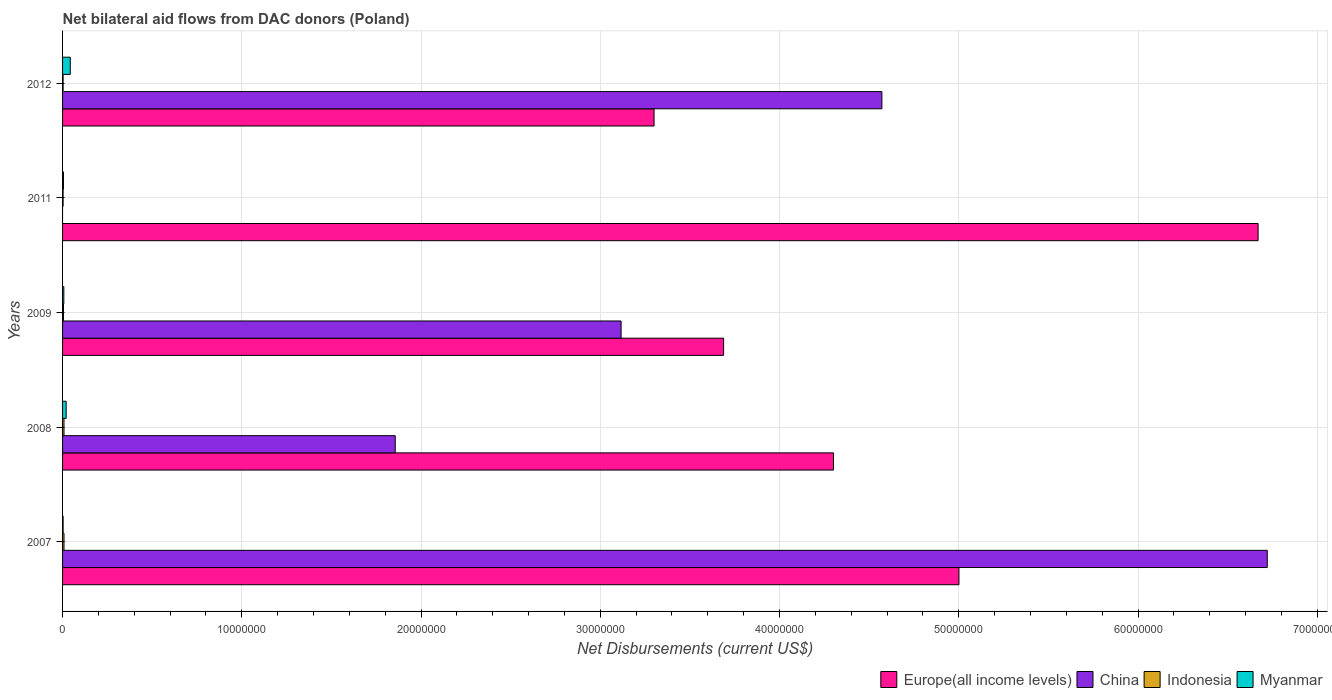How many different coloured bars are there?
Offer a very short reply. 4. How many groups of bars are there?
Offer a very short reply. 5. How many bars are there on the 3rd tick from the bottom?
Ensure brevity in your answer.  4. In how many cases, is the number of bars for a given year not equal to the number of legend labels?
Provide a succinct answer. 1. What is the net bilateral aid flows in Europe(all income levels) in 2007?
Ensure brevity in your answer.  5.00e+07. Across all years, what is the maximum net bilateral aid flows in Europe(all income levels)?
Ensure brevity in your answer.  6.67e+07. What is the total net bilateral aid flows in China in the graph?
Give a very brief answer. 1.63e+08. What is the difference between the net bilateral aid flows in Europe(all income levels) in 2007 and that in 2011?
Your answer should be very brief. -1.67e+07. What is the difference between the net bilateral aid flows in Indonesia in 2007 and the net bilateral aid flows in Europe(all income levels) in 2012?
Your answer should be compact. -3.29e+07. What is the average net bilateral aid flows in Europe(all income levels) per year?
Make the answer very short. 4.59e+07. In the year 2007, what is the difference between the net bilateral aid flows in Indonesia and net bilateral aid flows in Europe(all income levels)?
Offer a very short reply. -4.99e+07. In how many years, is the net bilateral aid flows in China greater than 46000000 US$?
Provide a succinct answer. 1. What is the ratio of the net bilateral aid flows in Europe(all income levels) in 2008 to that in 2012?
Offer a terse response. 1.3. Is the net bilateral aid flows in Europe(all income levels) in 2007 less than that in 2009?
Make the answer very short. No. What is the difference between the highest and the second highest net bilateral aid flows in Europe(all income levels)?
Your answer should be compact. 1.67e+07. What is the difference between the highest and the lowest net bilateral aid flows in Indonesia?
Your answer should be very brief. 5.00e+04. In how many years, is the net bilateral aid flows in Myanmar greater than the average net bilateral aid flows in Myanmar taken over all years?
Your answer should be very brief. 2. Is it the case that in every year, the sum of the net bilateral aid flows in China and net bilateral aid flows in Indonesia is greater than the sum of net bilateral aid flows in Myanmar and net bilateral aid flows in Europe(all income levels)?
Give a very brief answer. No. Are the values on the major ticks of X-axis written in scientific E-notation?
Make the answer very short. No. Does the graph contain any zero values?
Your response must be concise. Yes. How are the legend labels stacked?
Make the answer very short. Horizontal. What is the title of the graph?
Your response must be concise. Net bilateral aid flows from DAC donors (Poland). What is the label or title of the X-axis?
Ensure brevity in your answer.  Net Disbursements (current US$). What is the label or title of the Y-axis?
Your answer should be compact. Years. What is the Net Disbursements (current US$) in Europe(all income levels) in 2007?
Your answer should be compact. 5.00e+07. What is the Net Disbursements (current US$) in China in 2007?
Your response must be concise. 6.72e+07. What is the Net Disbursements (current US$) of Indonesia in 2007?
Provide a short and direct response. 8.00e+04. What is the Net Disbursements (current US$) in Myanmar in 2007?
Provide a succinct answer. 3.00e+04. What is the Net Disbursements (current US$) of Europe(all income levels) in 2008?
Ensure brevity in your answer.  4.30e+07. What is the Net Disbursements (current US$) in China in 2008?
Ensure brevity in your answer.  1.86e+07. What is the Net Disbursements (current US$) in Indonesia in 2008?
Your answer should be compact. 8.00e+04. What is the Net Disbursements (current US$) of Myanmar in 2008?
Offer a terse response. 2.00e+05. What is the Net Disbursements (current US$) of Europe(all income levels) in 2009?
Your answer should be compact. 3.69e+07. What is the Net Disbursements (current US$) of China in 2009?
Offer a terse response. 3.12e+07. What is the Net Disbursements (current US$) of Indonesia in 2009?
Ensure brevity in your answer.  5.00e+04. What is the Net Disbursements (current US$) of Myanmar in 2009?
Offer a very short reply. 7.00e+04. What is the Net Disbursements (current US$) in Europe(all income levels) in 2011?
Give a very brief answer. 6.67e+07. What is the Net Disbursements (current US$) of China in 2011?
Provide a succinct answer. 0. What is the Net Disbursements (current US$) in Indonesia in 2011?
Keep it short and to the point. 3.00e+04. What is the Net Disbursements (current US$) in Europe(all income levels) in 2012?
Your answer should be compact. 3.30e+07. What is the Net Disbursements (current US$) in China in 2012?
Ensure brevity in your answer.  4.57e+07. What is the Net Disbursements (current US$) of Indonesia in 2012?
Your answer should be compact. 3.00e+04. Across all years, what is the maximum Net Disbursements (current US$) of Europe(all income levels)?
Offer a terse response. 6.67e+07. Across all years, what is the maximum Net Disbursements (current US$) in China?
Offer a very short reply. 6.72e+07. Across all years, what is the maximum Net Disbursements (current US$) of Indonesia?
Ensure brevity in your answer.  8.00e+04. Across all years, what is the maximum Net Disbursements (current US$) of Myanmar?
Make the answer very short. 4.30e+05. Across all years, what is the minimum Net Disbursements (current US$) of Europe(all income levels)?
Keep it short and to the point. 3.30e+07. What is the total Net Disbursements (current US$) in Europe(all income levels) in the graph?
Ensure brevity in your answer.  2.30e+08. What is the total Net Disbursements (current US$) of China in the graph?
Provide a succinct answer. 1.63e+08. What is the total Net Disbursements (current US$) of Indonesia in the graph?
Ensure brevity in your answer.  2.70e+05. What is the total Net Disbursements (current US$) in Myanmar in the graph?
Ensure brevity in your answer.  7.80e+05. What is the difference between the Net Disbursements (current US$) in Europe(all income levels) in 2007 and that in 2008?
Provide a short and direct response. 7.00e+06. What is the difference between the Net Disbursements (current US$) of China in 2007 and that in 2008?
Your answer should be compact. 4.86e+07. What is the difference between the Net Disbursements (current US$) of Myanmar in 2007 and that in 2008?
Your response must be concise. -1.70e+05. What is the difference between the Net Disbursements (current US$) in Europe(all income levels) in 2007 and that in 2009?
Your response must be concise. 1.31e+07. What is the difference between the Net Disbursements (current US$) of China in 2007 and that in 2009?
Ensure brevity in your answer.  3.60e+07. What is the difference between the Net Disbursements (current US$) in Europe(all income levels) in 2007 and that in 2011?
Your answer should be very brief. -1.67e+07. What is the difference between the Net Disbursements (current US$) in Indonesia in 2007 and that in 2011?
Offer a terse response. 5.00e+04. What is the difference between the Net Disbursements (current US$) of Europe(all income levels) in 2007 and that in 2012?
Your answer should be very brief. 1.70e+07. What is the difference between the Net Disbursements (current US$) of China in 2007 and that in 2012?
Provide a succinct answer. 2.15e+07. What is the difference between the Net Disbursements (current US$) of Indonesia in 2007 and that in 2012?
Offer a terse response. 5.00e+04. What is the difference between the Net Disbursements (current US$) of Myanmar in 2007 and that in 2012?
Your answer should be compact. -4.00e+05. What is the difference between the Net Disbursements (current US$) in Europe(all income levels) in 2008 and that in 2009?
Offer a very short reply. 6.13e+06. What is the difference between the Net Disbursements (current US$) in China in 2008 and that in 2009?
Keep it short and to the point. -1.26e+07. What is the difference between the Net Disbursements (current US$) of Myanmar in 2008 and that in 2009?
Your answer should be compact. 1.30e+05. What is the difference between the Net Disbursements (current US$) of Europe(all income levels) in 2008 and that in 2011?
Provide a short and direct response. -2.37e+07. What is the difference between the Net Disbursements (current US$) of Indonesia in 2008 and that in 2011?
Your answer should be compact. 5.00e+04. What is the difference between the Net Disbursements (current US$) in Europe(all income levels) in 2008 and that in 2012?
Your answer should be very brief. 1.00e+07. What is the difference between the Net Disbursements (current US$) of China in 2008 and that in 2012?
Make the answer very short. -2.72e+07. What is the difference between the Net Disbursements (current US$) of Indonesia in 2008 and that in 2012?
Your response must be concise. 5.00e+04. What is the difference between the Net Disbursements (current US$) in Europe(all income levels) in 2009 and that in 2011?
Your answer should be very brief. -2.98e+07. What is the difference between the Net Disbursements (current US$) in Indonesia in 2009 and that in 2011?
Ensure brevity in your answer.  2.00e+04. What is the difference between the Net Disbursements (current US$) in Europe(all income levels) in 2009 and that in 2012?
Your answer should be very brief. 3.88e+06. What is the difference between the Net Disbursements (current US$) of China in 2009 and that in 2012?
Provide a short and direct response. -1.46e+07. What is the difference between the Net Disbursements (current US$) of Myanmar in 2009 and that in 2012?
Provide a succinct answer. -3.60e+05. What is the difference between the Net Disbursements (current US$) in Europe(all income levels) in 2011 and that in 2012?
Your answer should be compact. 3.37e+07. What is the difference between the Net Disbursements (current US$) in Myanmar in 2011 and that in 2012?
Ensure brevity in your answer.  -3.80e+05. What is the difference between the Net Disbursements (current US$) in Europe(all income levels) in 2007 and the Net Disbursements (current US$) in China in 2008?
Your answer should be compact. 3.14e+07. What is the difference between the Net Disbursements (current US$) of Europe(all income levels) in 2007 and the Net Disbursements (current US$) of Indonesia in 2008?
Offer a very short reply. 4.99e+07. What is the difference between the Net Disbursements (current US$) in Europe(all income levels) in 2007 and the Net Disbursements (current US$) in Myanmar in 2008?
Your answer should be very brief. 4.98e+07. What is the difference between the Net Disbursements (current US$) of China in 2007 and the Net Disbursements (current US$) of Indonesia in 2008?
Your answer should be compact. 6.71e+07. What is the difference between the Net Disbursements (current US$) in China in 2007 and the Net Disbursements (current US$) in Myanmar in 2008?
Your response must be concise. 6.70e+07. What is the difference between the Net Disbursements (current US$) in Europe(all income levels) in 2007 and the Net Disbursements (current US$) in China in 2009?
Your answer should be very brief. 1.88e+07. What is the difference between the Net Disbursements (current US$) in Europe(all income levels) in 2007 and the Net Disbursements (current US$) in Indonesia in 2009?
Your answer should be very brief. 5.00e+07. What is the difference between the Net Disbursements (current US$) in Europe(all income levels) in 2007 and the Net Disbursements (current US$) in Myanmar in 2009?
Offer a very short reply. 4.99e+07. What is the difference between the Net Disbursements (current US$) of China in 2007 and the Net Disbursements (current US$) of Indonesia in 2009?
Keep it short and to the point. 6.72e+07. What is the difference between the Net Disbursements (current US$) in China in 2007 and the Net Disbursements (current US$) in Myanmar in 2009?
Provide a succinct answer. 6.71e+07. What is the difference between the Net Disbursements (current US$) of Europe(all income levels) in 2007 and the Net Disbursements (current US$) of Indonesia in 2011?
Your answer should be compact. 5.00e+07. What is the difference between the Net Disbursements (current US$) of Europe(all income levels) in 2007 and the Net Disbursements (current US$) of Myanmar in 2011?
Offer a very short reply. 5.00e+07. What is the difference between the Net Disbursements (current US$) of China in 2007 and the Net Disbursements (current US$) of Indonesia in 2011?
Offer a terse response. 6.72e+07. What is the difference between the Net Disbursements (current US$) of China in 2007 and the Net Disbursements (current US$) of Myanmar in 2011?
Provide a short and direct response. 6.72e+07. What is the difference between the Net Disbursements (current US$) in Indonesia in 2007 and the Net Disbursements (current US$) in Myanmar in 2011?
Your answer should be very brief. 3.00e+04. What is the difference between the Net Disbursements (current US$) of Europe(all income levels) in 2007 and the Net Disbursements (current US$) of China in 2012?
Your response must be concise. 4.30e+06. What is the difference between the Net Disbursements (current US$) in Europe(all income levels) in 2007 and the Net Disbursements (current US$) in Indonesia in 2012?
Your response must be concise. 5.00e+07. What is the difference between the Net Disbursements (current US$) in Europe(all income levels) in 2007 and the Net Disbursements (current US$) in Myanmar in 2012?
Ensure brevity in your answer.  4.96e+07. What is the difference between the Net Disbursements (current US$) of China in 2007 and the Net Disbursements (current US$) of Indonesia in 2012?
Offer a terse response. 6.72e+07. What is the difference between the Net Disbursements (current US$) of China in 2007 and the Net Disbursements (current US$) of Myanmar in 2012?
Offer a very short reply. 6.68e+07. What is the difference between the Net Disbursements (current US$) of Indonesia in 2007 and the Net Disbursements (current US$) of Myanmar in 2012?
Provide a succinct answer. -3.50e+05. What is the difference between the Net Disbursements (current US$) in Europe(all income levels) in 2008 and the Net Disbursements (current US$) in China in 2009?
Offer a terse response. 1.18e+07. What is the difference between the Net Disbursements (current US$) of Europe(all income levels) in 2008 and the Net Disbursements (current US$) of Indonesia in 2009?
Offer a terse response. 4.30e+07. What is the difference between the Net Disbursements (current US$) in Europe(all income levels) in 2008 and the Net Disbursements (current US$) in Myanmar in 2009?
Your answer should be compact. 4.29e+07. What is the difference between the Net Disbursements (current US$) in China in 2008 and the Net Disbursements (current US$) in Indonesia in 2009?
Your answer should be very brief. 1.85e+07. What is the difference between the Net Disbursements (current US$) in China in 2008 and the Net Disbursements (current US$) in Myanmar in 2009?
Your response must be concise. 1.85e+07. What is the difference between the Net Disbursements (current US$) of Europe(all income levels) in 2008 and the Net Disbursements (current US$) of Indonesia in 2011?
Your answer should be compact. 4.30e+07. What is the difference between the Net Disbursements (current US$) in Europe(all income levels) in 2008 and the Net Disbursements (current US$) in Myanmar in 2011?
Make the answer very short. 4.30e+07. What is the difference between the Net Disbursements (current US$) of China in 2008 and the Net Disbursements (current US$) of Indonesia in 2011?
Offer a very short reply. 1.85e+07. What is the difference between the Net Disbursements (current US$) of China in 2008 and the Net Disbursements (current US$) of Myanmar in 2011?
Give a very brief answer. 1.85e+07. What is the difference between the Net Disbursements (current US$) in Europe(all income levels) in 2008 and the Net Disbursements (current US$) in China in 2012?
Your answer should be very brief. -2.70e+06. What is the difference between the Net Disbursements (current US$) in Europe(all income levels) in 2008 and the Net Disbursements (current US$) in Indonesia in 2012?
Your answer should be compact. 4.30e+07. What is the difference between the Net Disbursements (current US$) in Europe(all income levels) in 2008 and the Net Disbursements (current US$) in Myanmar in 2012?
Ensure brevity in your answer.  4.26e+07. What is the difference between the Net Disbursements (current US$) in China in 2008 and the Net Disbursements (current US$) in Indonesia in 2012?
Your response must be concise. 1.85e+07. What is the difference between the Net Disbursements (current US$) in China in 2008 and the Net Disbursements (current US$) in Myanmar in 2012?
Your answer should be compact. 1.81e+07. What is the difference between the Net Disbursements (current US$) in Indonesia in 2008 and the Net Disbursements (current US$) in Myanmar in 2012?
Make the answer very short. -3.50e+05. What is the difference between the Net Disbursements (current US$) in Europe(all income levels) in 2009 and the Net Disbursements (current US$) in Indonesia in 2011?
Provide a short and direct response. 3.68e+07. What is the difference between the Net Disbursements (current US$) in Europe(all income levels) in 2009 and the Net Disbursements (current US$) in Myanmar in 2011?
Your answer should be very brief. 3.68e+07. What is the difference between the Net Disbursements (current US$) of China in 2009 and the Net Disbursements (current US$) of Indonesia in 2011?
Provide a short and direct response. 3.11e+07. What is the difference between the Net Disbursements (current US$) in China in 2009 and the Net Disbursements (current US$) in Myanmar in 2011?
Your answer should be very brief. 3.11e+07. What is the difference between the Net Disbursements (current US$) in Indonesia in 2009 and the Net Disbursements (current US$) in Myanmar in 2011?
Keep it short and to the point. 0. What is the difference between the Net Disbursements (current US$) of Europe(all income levels) in 2009 and the Net Disbursements (current US$) of China in 2012?
Make the answer very short. -8.83e+06. What is the difference between the Net Disbursements (current US$) of Europe(all income levels) in 2009 and the Net Disbursements (current US$) of Indonesia in 2012?
Make the answer very short. 3.68e+07. What is the difference between the Net Disbursements (current US$) of Europe(all income levels) in 2009 and the Net Disbursements (current US$) of Myanmar in 2012?
Your answer should be compact. 3.64e+07. What is the difference between the Net Disbursements (current US$) of China in 2009 and the Net Disbursements (current US$) of Indonesia in 2012?
Offer a terse response. 3.11e+07. What is the difference between the Net Disbursements (current US$) of China in 2009 and the Net Disbursements (current US$) of Myanmar in 2012?
Ensure brevity in your answer.  3.07e+07. What is the difference between the Net Disbursements (current US$) of Indonesia in 2009 and the Net Disbursements (current US$) of Myanmar in 2012?
Keep it short and to the point. -3.80e+05. What is the difference between the Net Disbursements (current US$) of Europe(all income levels) in 2011 and the Net Disbursements (current US$) of China in 2012?
Your answer should be very brief. 2.10e+07. What is the difference between the Net Disbursements (current US$) of Europe(all income levels) in 2011 and the Net Disbursements (current US$) of Indonesia in 2012?
Offer a very short reply. 6.67e+07. What is the difference between the Net Disbursements (current US$) of Europe(all income levels) in 2011 and the Net Disbursements (current US$) of Myanmar in 2012?
Keep it short and to the point. 6.63e+07. What is the difference between the Net Disbursements (current US$) in Indonesia in 2011 and the Net Disbursements (current US$) in Myanmar in 2012?
Make the answer very short. -4.00e+05. What is the average Net Disbursements (current US$) of Europe(all income levels) per year?
Ensure brevity in your answer.  4.59e+07. What is the average Net Disbursements (current US$) in China per year?
Provide a short and direct response. 3.25e+07. What is the average Net Disbursements (current US$) of Indonesia per year?
Make the answer very short. 5.40e+04. What is the average Net Disbursements (current US$) of Myanmar per year?
Your answer should be compact. 1.56e+05. In the year 2007, what is the difference between the Net Disbursements (current US$) of Europe(all income levels) and Net Disbursements (current US$) of China?
Your answer should be compact. -1.72e+07. In the year 2007, what is the difference between the Net Disbursements (current US$) in Europe(all income levels) and Net Disbursements (current US$) in Indonesia?
Offer a terse response. 4.99e+07. In the year 2007, what is the difference between the Net Disbursements (current US$) in Europe(all income levels) and Net Disbursements (current US$) in Myanmar?
Make the answer very short. 5.00e+07. In the year 2007, what is the difference between the Net Disbursements (current US$) in China and Net Disbursements (current US$) in Indonesia?
Provide a succinct answer. 6.71e+07. In the year 2007, what is the difference between the Net Disbursements (current US$) of China and Net Disbursements (current US$) of Myanmar?
Ensure brevity in your answer.  6.72e+07. In the year 2007, what is the difference between the Net Disbursements (current US$) of Indonesia and Net Disbursements (current US$) of Myanmar?
Give a very brief answer. 5.00e+04. In the year 2008, what is the difference between the Net Disbursements (current US$) in Europe(all income levels) and Net Disbursements (current US$) in China?
Your answer should be very brief. 2.44e+07. In the year 2008, what is the difference between the Net Disbursements (current US$) in Europe(all income levels) and Net Disbursements (current US$) in Indonesia?
Offer a terse response. 4.29e+07. In the year 2008, what is the difference between the Net Disbursements (current US$) of Europe(all income levels) and Net Disbursements (current US$) of Myanmar?
Offer a very short reply. 4.28e+07. In the year 2008, what is the difference between the Net Disbursements (current US$) of China and Net Disbursements (current US$) of Indonesia?
Give a very brief answer. 1.85e+07. In the year 2008, what is the difference between the Net Disbursements (current US$) in China and Net Disbursements (current US$) in Myanmar?
Make the answer very short. 1.84e+07. In the year 2008, what is the difference between the Net Disbursements (current US$) of Indonesia and Net Disbursements (current US$) of Myanmar?
Keep it short and to the point. -1.20e+05. In the year 2009, what is the difference between the Net Disbursements (current US$) in Europe(all income levels) and Net Disbursements (current US$) in China?
Give a very brief answer. 5.72e+06. In the year 2009, what is the difference between the Net Disbursements (current US$) of Europe(all income levels) and Net Disbursements (current US$) of Indonesia?
Make the answer very short. 3.68e+07. In the year 2009, what is the difference between the Net Disbursements (current US$) in Europe(all income levels) and Net Disbursements (current US$) in Myanmar?
Your answer should be compact. 3.68e+07. In the year 2009, what is the difference between the Net Disbursements (current US$) in China and Net Disbursements (current US$) in Indonesia?
Ensure brevity in your answer.  3.11e+07. In the year 2009, what is the difference between the Net Disbursements (current US$) in China and Net Disbursements (current US$) in Myanmar?
Ensure brevity in your answer.  3.11e+07. In the year 2009, what is the difference between the Net Disbursements (current US$) of Indonesia and Net Disbursements (current US$) of Myanmar?
Your response must be concise. -2.00e+04. In the year 2011, what is the difference between the Net Disbursements (current US$) in Europe(all income levels) and Net Disbursements (current US$) in Indonesia?
Your answer should be compact. 6.67e+07. In the year 2011, what is the difference between the Net Disbursements (current US$) in Europe(all income levels) and Net Disbursements (current US$) in Myanmar?
Offer a terse response. 6.66e+07. In the year 2012, what is the difference between the Net Disbursements (current US$) of Europe(all income levels) and Net Disbursements (current US$) of China?
Your answer should be compact. -1.27e+07. In the year 2012, what is the difference between the Net Disbursements (current US$) in Europe(all income levels) and Net Disbursements (current US$) in Indonesia?
Keep it short and to the point. 3.30e+07. In the year 2012, what is the difference between the Net Disbursements (current US$) of Europe(all income levels) and Net Disbursements (current US$) of Myanmar?
Your answer should be compact. 3.26e+07. In the year 2012, what is the difference between the Net Disbursements (current US$) in China and Net Disbursements (current US$) in Indonesia?
Your response must be concise. 4.57e+07. In the year 2012, what is the difference between the Net Disbursements (current US$) of China and Net Disbursements (current US$) of Myanmar?
Offer a very short reply. 4.53e+07. In the year 2012, what is the difference between the Net Disbursements (current US$) of Indonesia and Net Disbursements (current US$) of Myanmar?
Your response must be concise. -4.00e+05. What is the ratio of the Net Disbursements (current US$) of Europe(all income levels) in 2007 to that in 2008?
Your answer should be compact. 1.16. What is the ratio of the Net Disbursements (current US$) of China in 2007 to that in 2008?
Keep it short and to the point. 3.62. What is the ratio of the Net Disbursements (current US$) in Indonesia in 2007 to that in 2008?
Your answer should be very brief. 1. What is the ratio of the Net Disbursements (current US$) in Myanmar in 2007 to that in 2008?
Offer a terse response. 0.15. What is the ratio of the Net Disbursements (current US$) in Europe(all income levels) in 2007 to that in 2009?
Make the answer very short. 1.36. What is the ratio of the Net Disbursements (current US$) in China in 2007 to that in 2009?
Your response must be concise. 2.16. What is the ratio of the Net Disbursements (current US$) of Indonesia in 2007 to that in 2009?
Your answer should be very brief. 1.6. What is the ratio of the Net Disbursements (current US$) in Myanmar in 2007 to that in 2009?
Your answer should be very brief. 0.43. What is the ratio of the Net Disbursements (current US$) of Europe(all income levels) in 2007 to that in 2011?
Your response must be concise. 0.75. What is the ratio of the Net Disbursements (current US$) of Indonesia in 2007 to that in 2011?
Give a very brief answer. 2.67. What is the ratio of the Net Disbursements (current US$) of Myanmar in 2007 to that in 2011?
Ensure brevity in your answer.  0.6. What is the ratio of the Net Disbursements (current US$) in Europe(all income levels) in 2007 to that in 2012?
Provide a succinct answer. 1.52. What is the ratio of the Net Disbursements (current US$) in China in 2007 to that in 2012?
Give a very brief answer. 1.47. What is the ratio of the Net Disbursements (current US$) of Indonesia in 2007 to that in 2012?
Keep it short and to the point. 2.67. What is the ratio of the Net Disbursements (current US$) of Myanmar in 2007 to that in 2012?
Keep it short and to the point. 0.07. What is the ratio of the Net Disbursements (current US$) of Europe(all income levels) in 2008 to that in 2009?
Your answer should be compact. 1.17. What is the ratio of the Net Disbursements (current US$) in China in 2008 to that in 2009?
Give a very brief answer. 0.6. What is the ratio of the Net Disbursements (current US$) of Indonesia in 2008 to that in 2009?
Your response must be concise. 1.6. What is the ratio of the Net Disbursements (current US$) of Myanmar in 2008 to that in 2009?
Keep it short and to the point. 2.86. What is the ratio of the Net Disbursements (current US$) in Europe(all income levels) in 2008 to that in 2011?
Give a very brief answer. 0.64. What is the ratio of the Net Disbursements (current US$) in Indonesia in 2008 to that in 2011?
Make the answer very short. 2.67. What is the ratio of the Net Disbursements (current US$) of Myanmar in 2008 to that in 2011?
Give a very brief answer. 4. What is the ratio of the Net Disbursements (current US$) in Europe(all income levels) in 2008 to that in 2012?
Offer a terse response. 1.3. What is the ratio of the Net Disbursements (current US$) of China in 2008 to that in 2012?
Your answer should be very brief. 0.41. What is the ratio of the Net Disbursements (current US$) of Indonesia in 2008 to that in 2012?
Your answer should be very brief. 2.67. What is the ratio of the Net Disbursements (current US$) in Myanmar in 2008 to that in 2012?
Your response must be concise. 0.47. What is the ratio of the Net Disbursements (current US$) of Europe(all income levels) in 2009 to that in 2011?
Keep it short and to the point. 0.55. What is the ratio of the Net Disbursements (current US$) in Indonesia in 2009 to that in 2011?
Provide a succinct answer. 1.67. What is the ratio of the Net Disbursements (current US$) in Myanmar in 2009 to that in 2011?
Make the answer very short. 1.4. What is the ratio of the Net Disbursements (current US$) of Europe(all income levels) in 2009 to that in 2012?
Provide a short and direct response. 1.12. What is the ratio of the Net Disbursements (current US$) of China in 2009 to that in 2012?
Your response must be concise. 0.68. What is the ratio of the Net Disbursements (current US$) of Indonesia in 2009 to that in 2012?
Offer a terse response. 1.67. What is the ratio of the Net Disbursements (current US$) of Myanmar in 2009 to that in 2012?
Provide a short and direct response. 0.16. What is the ratio of the Net Disbursements (current US$) of Europe(all income levels) in 2011 to that in 2012?
Provide a short and direct response. 2.02. What is the ratio of the Net Disbursements (current US$) in Myanmar in 2011 to that in 2012?
Your answer should be very brief. 0.12. What is the difference between the highest and the second highest Net Disbursements (current US$) of Europe(all income levels)?
Offer a terse response. 1.67e+07. What is the difference between the highest and the second highest Net Disbursements (current US$) of China?
Give a very brief answer. 2.15e+07. What is the difference between the highest and the lowest Net Disbursements (current US$) of Europe(all income levels)?
Offer a terse response. 3.37e+07. What is the difference between the highest and the lowest Net Disbursements (current US$) of China?
Keep it short and to the point. 6.72e+07. What is the difference between the highest and the lowest Net Disbursements (current US$) in Indonesia?
Keep it short and to the point. 5.00e+04. 